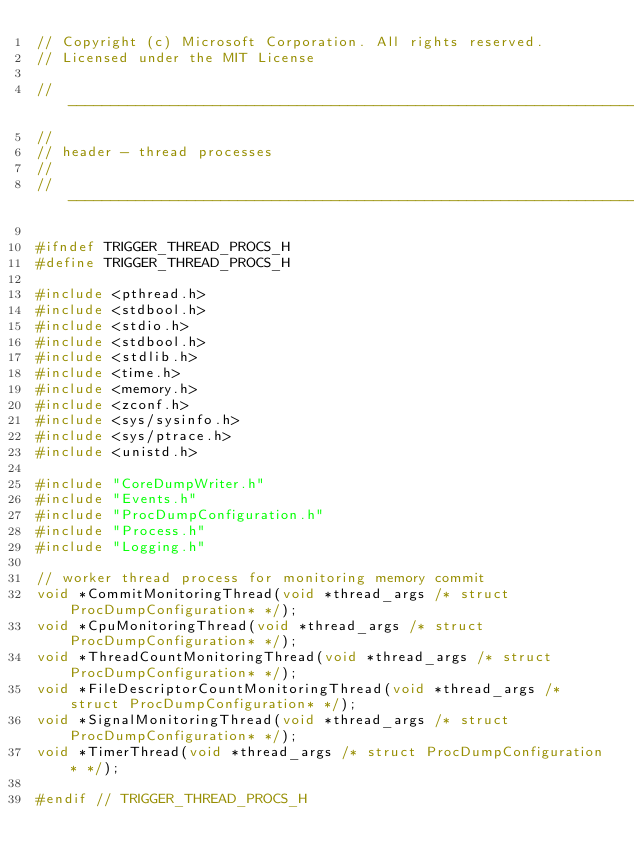<code> <loc_0><loc_0><loc_500><loc_500><_C_>// Copyright (c) Microsoft Corporation. All rights reserved.
// Licensed under the MIT License

//--------------------------------------------------------------------
//
// header - thread processes
//
//--------------------------------------------------------------------

#ifndef TRIGGER_THREAD_PROCS_H
#define TRIGGER_THREAD_PROCS_H

#include <pthread.h>
#include <stdbool.h>
#include <stdio.h>
#include <stdbool.h>
#include <stdlib.h>
#include <time.h>
#include <memory.h>
#include <zconf.h>
#include <sys/sysinfo.h>
#include <sys/ptrace.h>
#include <unistd.h>

#include "CoreDumpWriter.h"
#include "Events.h"
#include "ProcDumpConfiguration.h"
#include "Process.h"
#include "Logging.h"

// worker thread process for monitoring memory commit
void *CommitMonitoringThread(void *thread_args /* struct ProcDumpConfiguration* */);
void *CpuMonitoringThread(void *thread_args /* struct ProcDumpConfiguration* */);
void *ThreadCountMonitoringThread(void *thread_args /* struct ProcDumpConfiguration* */);
void *FileDescriptorCountMonitoringThread(void *thread_args /* struct ProcDumpConfiguration* */);
void *SignalMonitoringThread(void *thread_args /* struct ProcDumpConfiguration* */);
void *TimerThread(void *thread_args /* struct ProcDumpConfiguration* */);

#endif // TRIGGER_THREAD_PROCS_H</code> 